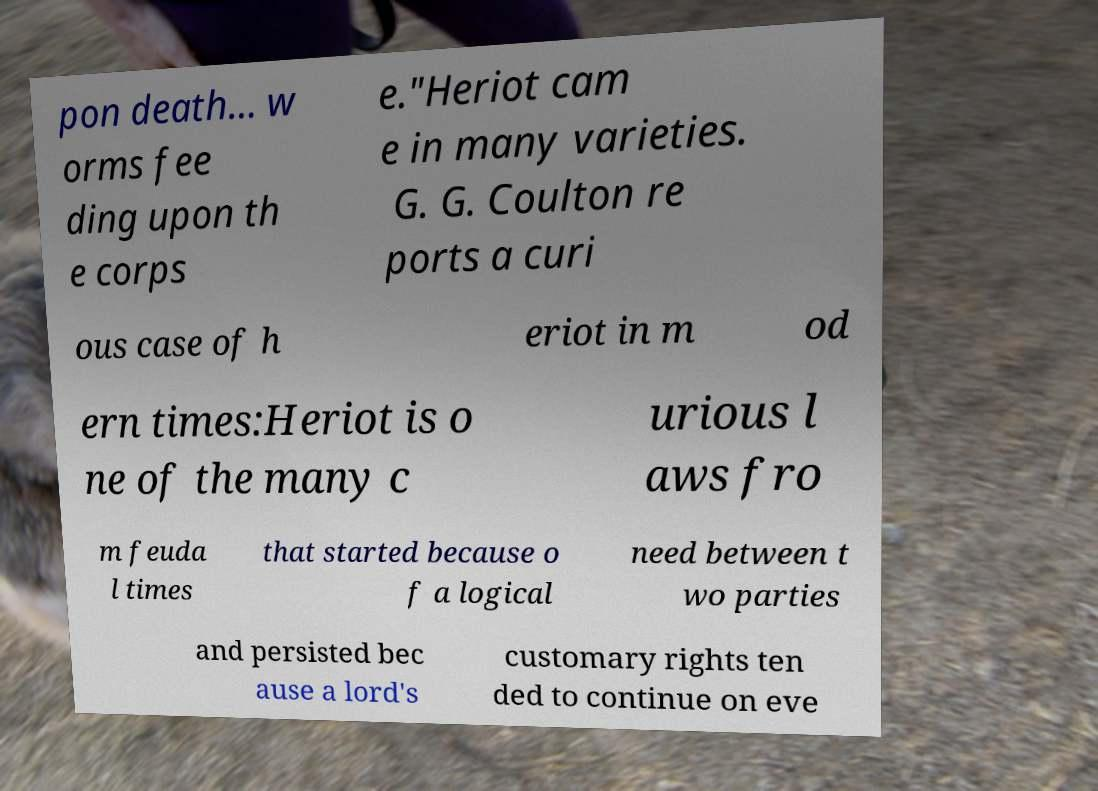Can you read and provide the text displayed in the image?This photo seems to have some interesting text. Can you extract and type it out for me? pon death... w orms fee ding upon th e corps e."Heriot cam e in many varieties. G. G. Coulton re ports a curi ous case of h eriot in m od ern times:Heriot is o ne of the many c urious l aws fro m feuda l times that started because o f a logical need between t wo parties and persisted bec ause a lord's customary rights ten ded to continue on eve 